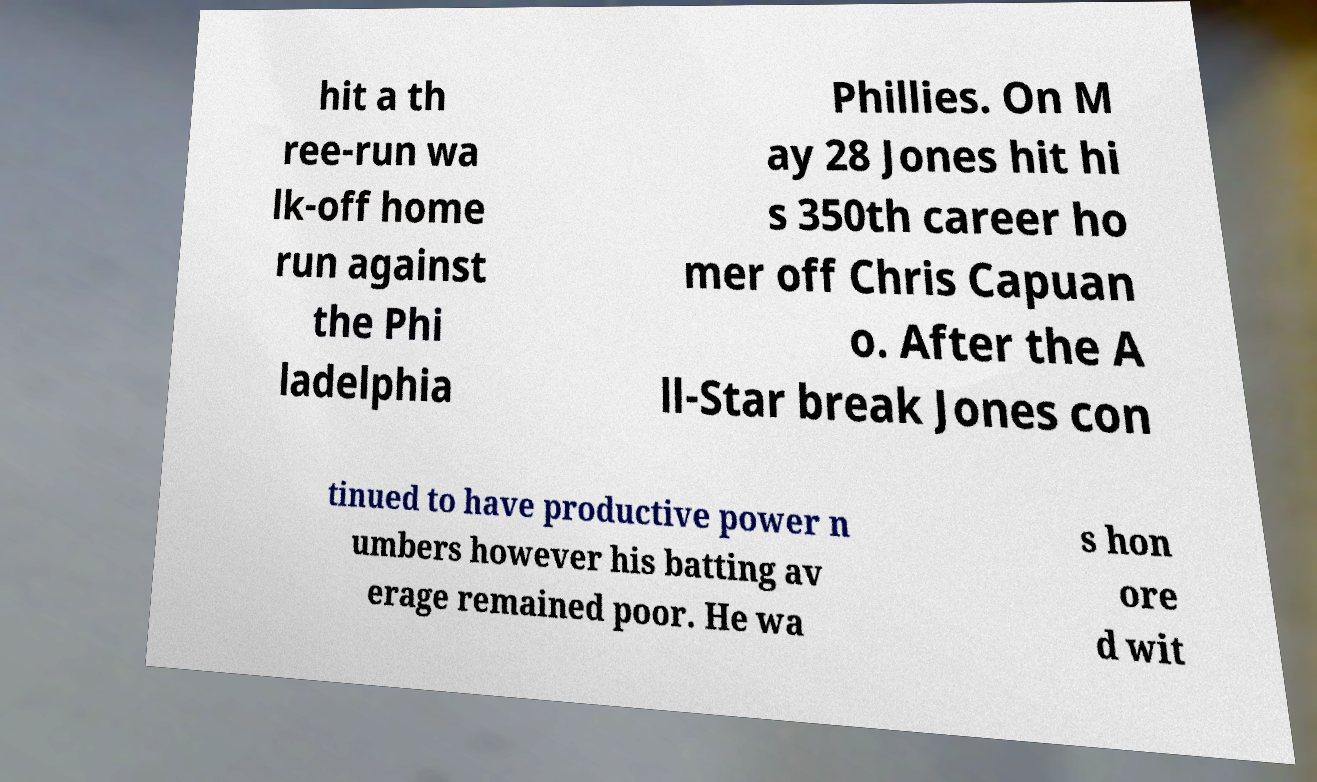I need the written content from this picture converted into text. Can you do that? hit a th ree-run wa lk-off home run against the Phi ladelphia Phillies. On M ay 28 Jones hit hi s 350th career ho mer off Chris Capuan o. After the A ll-Star break Jones con tinued to have productive power n umbers however his batting av erage remained poor. He wa s hon ore d wit 